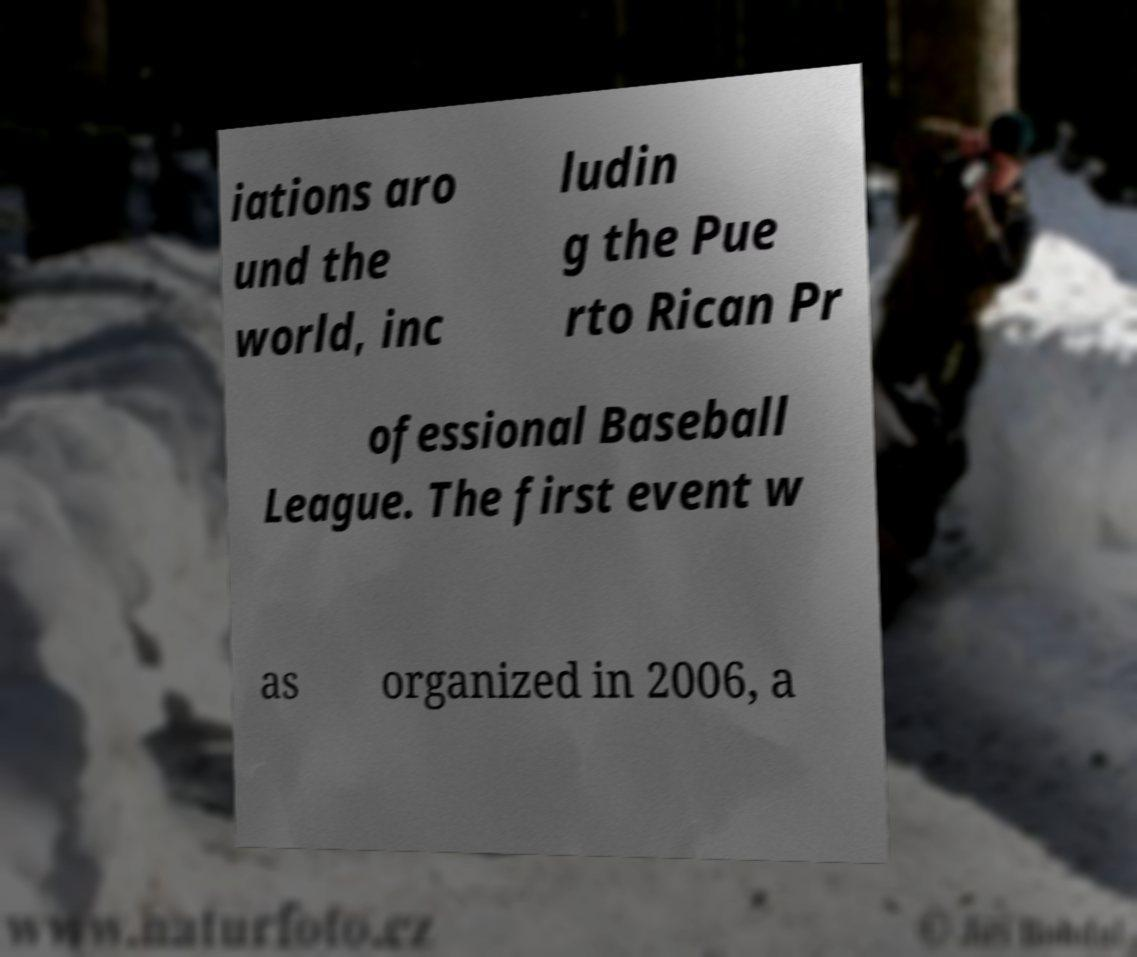Please identify and transcribe the text found in this image. iations aro und the world, inc ludin g the Pue rto Rican Pr ofessional Baseball League. The first event w as organized in 2006, a 